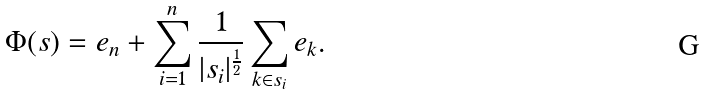Convert formula to latex. <formula><loc_0><loc_0><loc_500><loc_500>\Phi ( s ) = e _ { n } + \sum _ { i = 1 } ^ { n } \frac { 1 } { | s _ { i } | ^ { \frac { 1 } { 2 } } } \sum _ { k \in s _ { i } } e _ { k } .</formula> 